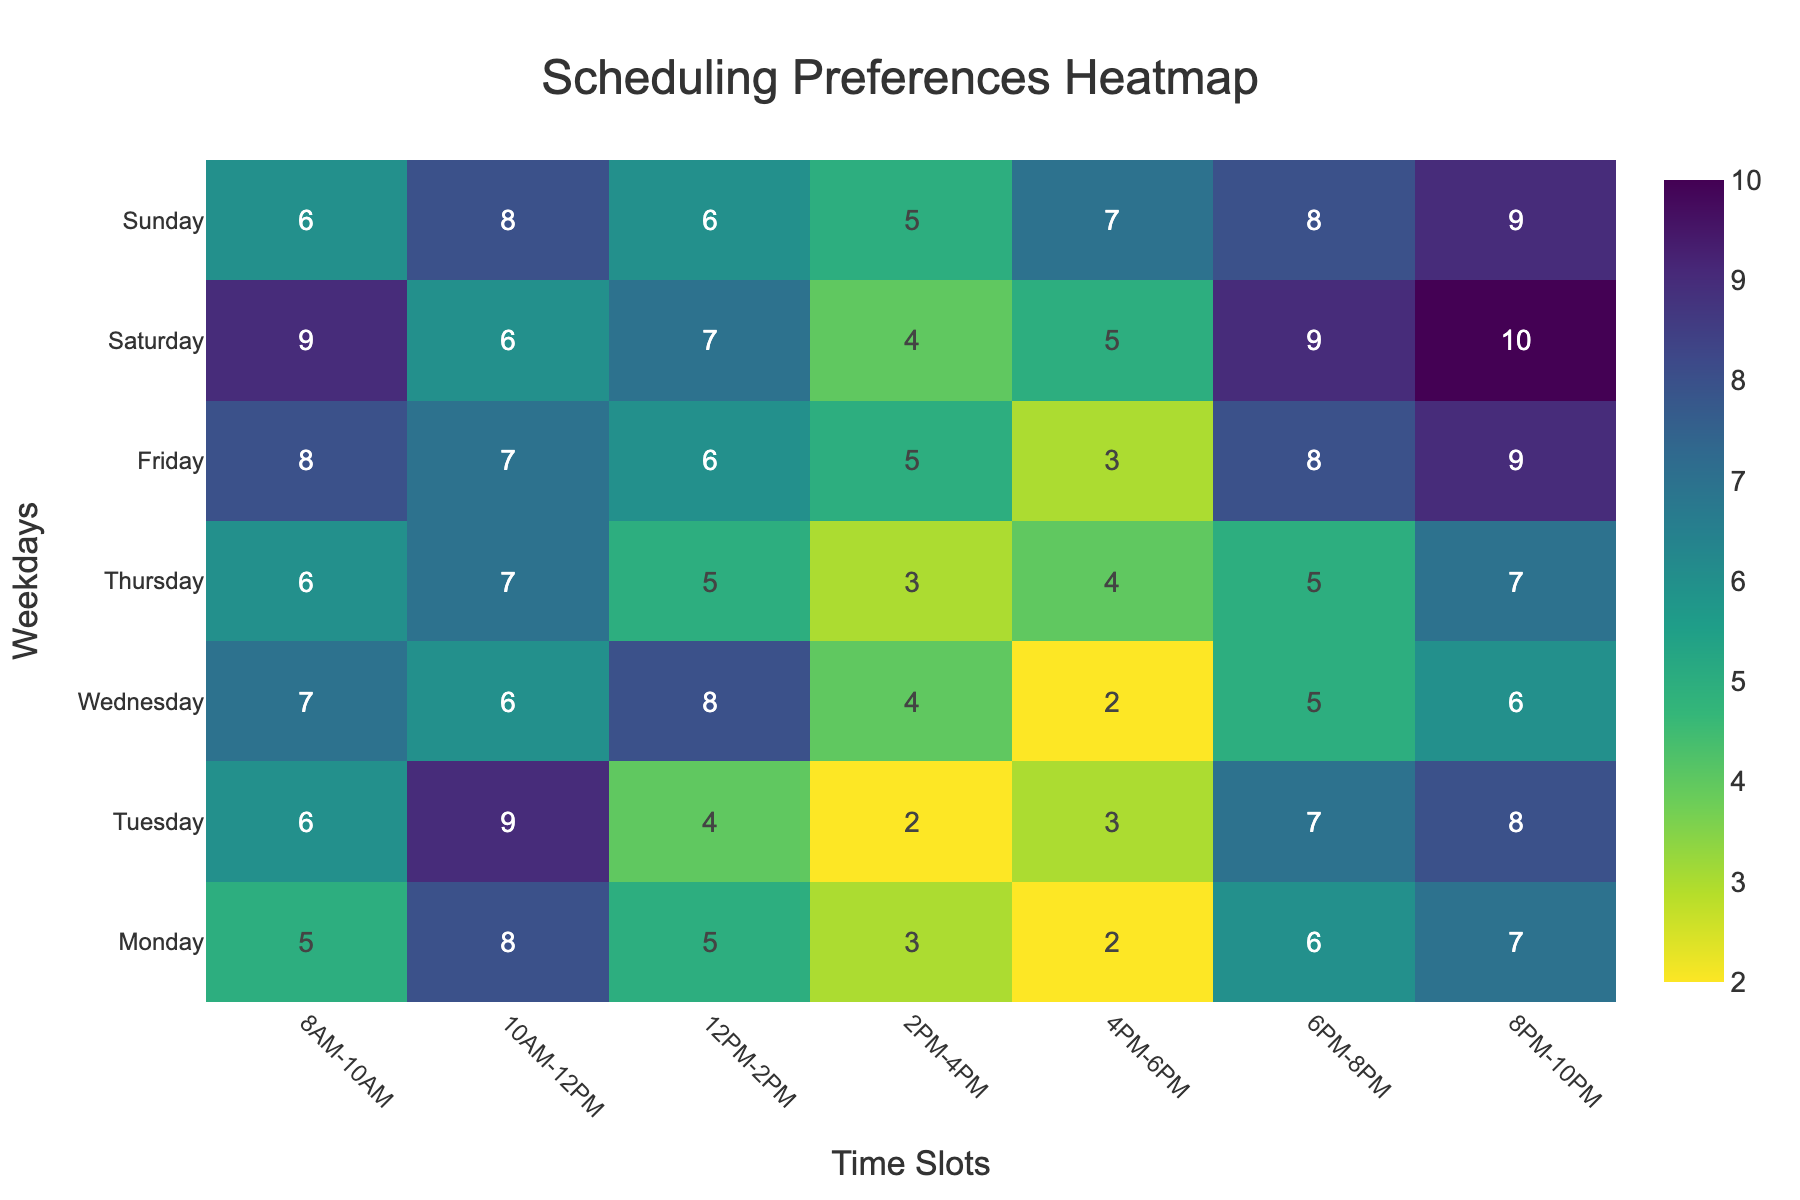what is the title of the heatmap? The title of the heatmap is located at the top center of the figure in a large font. It is "Scheduling Preferences Heatmap"
Answer: Scheduling Preferences Heatmap On which day and time slot is the preference highest? The highest preference is represented by the darkest color (or the highest value) in the heatmap. This highest value is located at the intersection of Saturday and 8PM-10PM
Answer: Saturday, 8PM-10PM What is the preference for Tuesday from 2PM-4PM? Find the value at the intersection of Tuesday and the 2PM-4PM time slot. The value is 2, which can also be identified by its color shade.
Answer: 2 Which weekday has the most uniformly distributed preferences throughout the day? Uniform distribution indicates that values do not vary much from one time slot to another. Comparing the values for each weekday, Thursday shows more uniform preferences with values being 6, 7, 5, 3, 4, 5, and 7.
Answer: Thursday What's the total preference count for Wednesday? Sum the values across all time slots for Wednesday: 7 (8AM-10AM) + 6 (10AM-12PM) + 8 (12PM-2PM) + 4 (2PM-4PM) + 2 (4PM-6PM) + 5 (6PM-8PM) + 6 (8PM-10PM). The sum is 38.
Answer: 38 Which time slot has the lowest overall preference across all weekdays? Add all the preferences for each time slot across all days and compare: e.g., 8AM-10AM = 5+6+7+6+8+9+6 = 47, 4PM-6PM = 2+3+2+4+3+5+7 = 26 etc. The lowest overall value is for the 4PM-6PM slot with a sum of 26.
Answer: 4PM-6PM Are there any time slots with a preference count of 5 on both weekdays and weekends? Check the matrix to see if the value 5 appears on a weekday and a weekend at the same time slot: 8AM-10AM on both Monday and Saturday, 12PM-2PM on both Monday and Saturday, 8PM-10PM on both Monday and Thursday.
Answer: Yes Which weekday time slot from 10AM-12PM has the highest preference? Check values in the 10AM-12PM column and find the maximum: Monday (8), Tuesday (9), Wednesday (6), Thursday (7), Friday (7). The highest value is 9 on Tuesday.
Answer: Tuesday What is the sum of preferences for the weekend's evening (6PM-8PM and 8PM-10PM) slots? Sum the preferences for Saturday and Sunday for the 6PM-8PM and 8PM-10PM slots: Saturday: 9 (6PM-8PM) + 10 (8PM-10PM) = 19, Sunday: 8 (6PM-8PM) + 9 (8PM-10PM) = 17. So, 19 + 17 = 36.
Answer: 36 Which time slot shows a preference difference of exactly 2 between any two consecutive weekdays? To determine this, compare values for each time slot on consecutive weekdays: 6PM-8PM on Monday (6) and Tuesday (7); 12PM-2PM on Monday (5) and Tuesday (4); 6PM-8PM on Tuesday (7) and Wednesday (5); 2PM-4PM on Tuesday (2) and Wednesday (4). Valid slot is 2PM-4PM between Monday (3) and Tuesday (2).
Answer: 2PM-4PM 